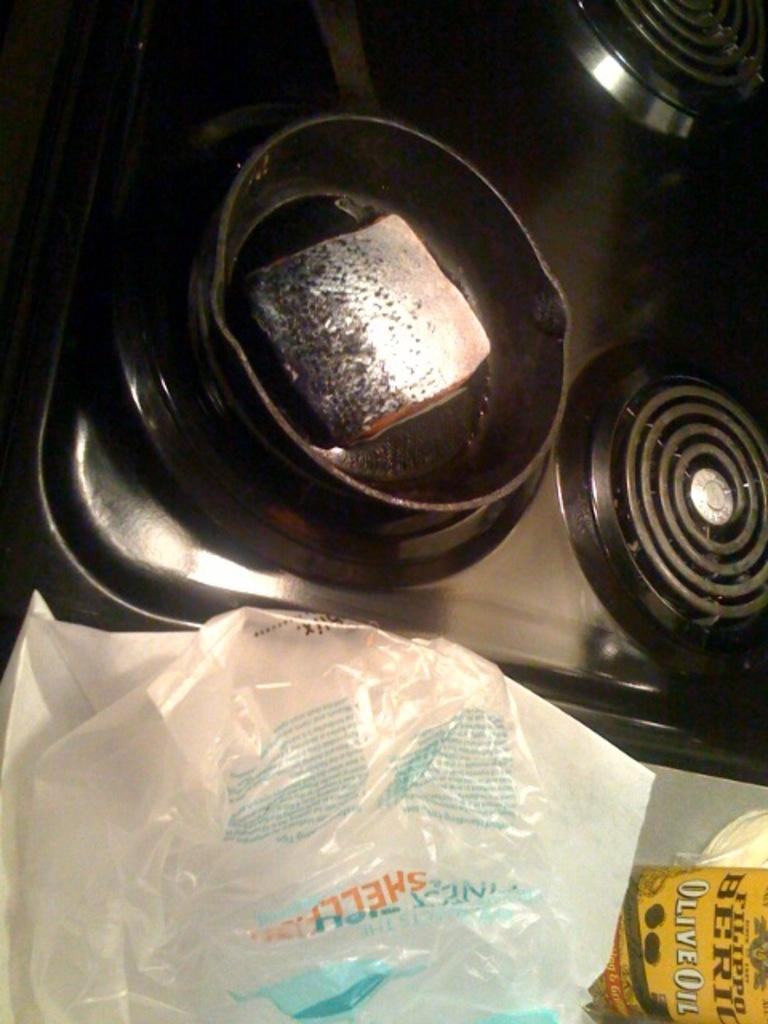What is in the bowl that is visible in the image? There is a bowl of food visible in the image. What cooking appliance can be seen in the image? There is a stove in the image. What type of covering is present in the image? Plastic covers are present in the image. What type of crime is being committed in the image? There is no crime being committed in the image; it features a bowl of food, a stove, and plastic covers. What scientific theory is being demonstrated in the image? There is no scientific theory being demonstrated in the image; it features a bowl of food, a stove, and plastic covers. 